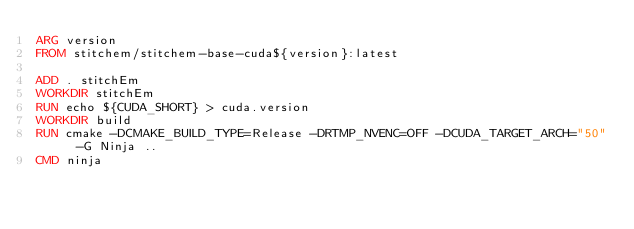<code> <loc_0><loc_0><loc_500><loc_500><_Dockerfile_>ARG version
FROM stitchem/stitchem-base-cuda${version}:latest

ADD . stitchEm
WORKDIR stitchEm
RUN echo ${CUDA_SHORT} > cuda.version
WORKDIR build
RUN cmake -DCMAKE_BUILD_TYPE=Release -DRTMP_NVENC=OFF -DCUDA_TARGET_ARCH="50" -G Ninja ..
CMD ninja
</code> 